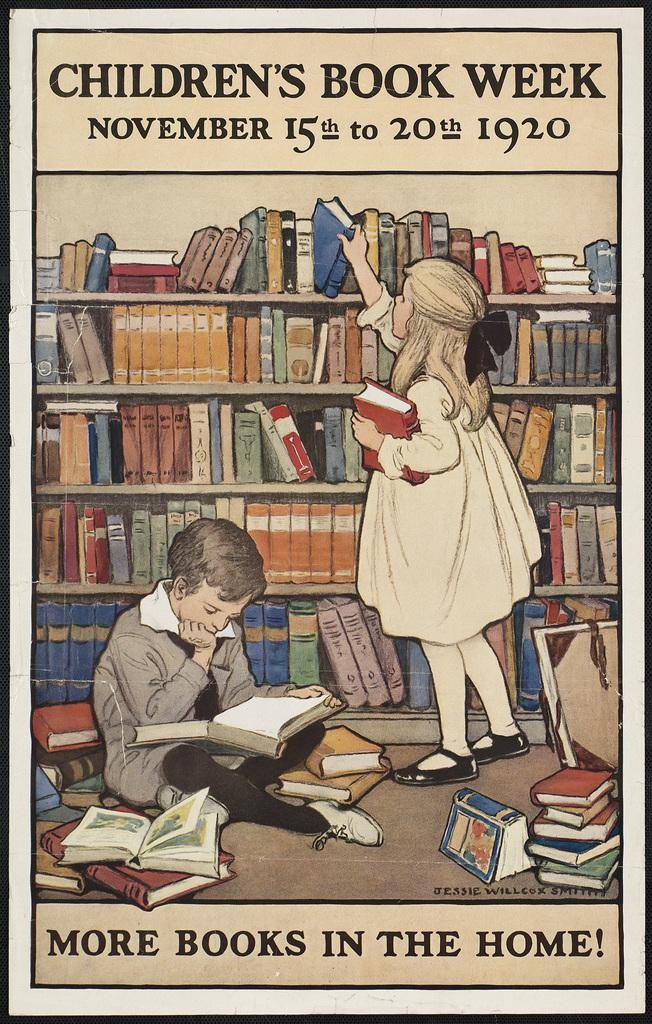<image>
Write a terse but informative summary of the picture. two children listed in a poster that mentions Children's book week on November 15th to 20th in the year 1920. 